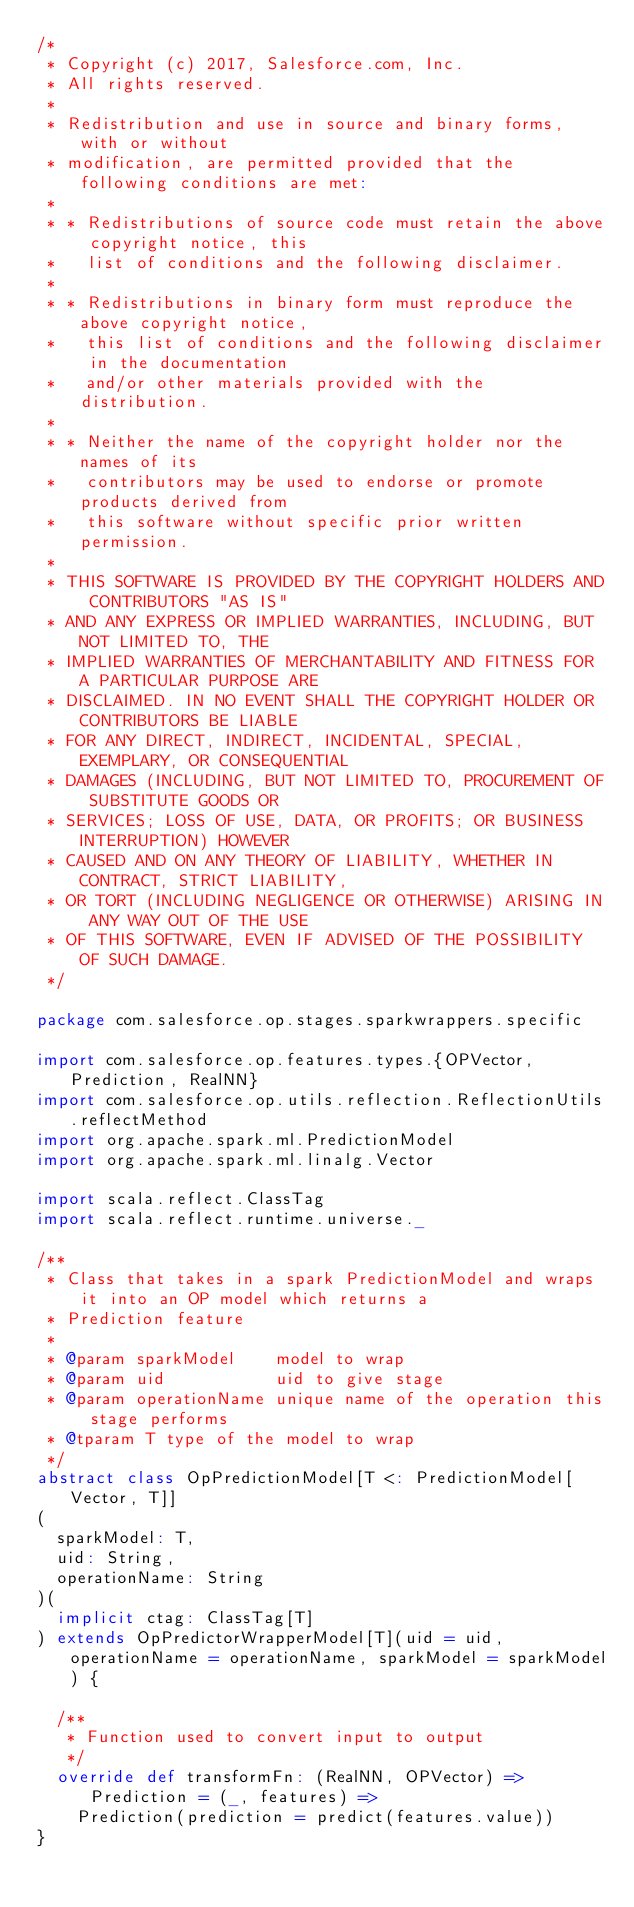<code> <loc_0><loc_0><loc_500><loc_500><_Scala_>/*
 * Copyright (c) 2017, Salesforce.com, Inc.
 * All rights reserved.
 *
 * Redistribution and use in source and binary forms, with or without
 * modification, are permitted provided that the following conditions are met:
 *
 * * Redistributions of source code must retain the above copyright notice, this
 *   list of conditions and the following disclaimer.
 *
 * * Redistributions in binary form must reproduce the above copyright notice,
 *   this list of conditions and the following disclaimer in the documentation
 *   and/or other materials provided with the distribution.
 *
 * * Neither the name of the copyright holder nor the names of its
 *   contributors may be used to endorse or promote products derived from
 *   this software without specific prior written permission.
 *
 * THIS SOFTWARE IS PROVIDED BY THE COPYRIGHT HOLDERS AND CONTRIBUTORS "AS IS"
 * AND ANY EXPRESS OR IMPLIED WARRANTIES, INCLUDING, BUT NOT LIMITED TO, THE
 * IMPLIED WARRANTIES OF MERCHANTABILITY AND FITNESS FOR A PARTICULAR PURPOSE ARE
 * DISCLAIMED. IN NO EVENT SHALL THE COPYRIGHT HOLDER OR CONTRIBUTORS BE LIABLE
 * FOR ANY DIRECT, INDIRECT, INCIDENTAL, SPECIAL, EXEMPLARY, OR CONSEQUENTIAL
 * DAMAGES (INCLUDING, BUT NOT LIMITED TO, PROCUREMENT OF SUBSTITUTE GOODS OR
 * SERVICES; LOSS OF USE, DATA, OR PROFITS; OR BUSINESS INTERRUPTION) HOWEVER
 * CAUSED AND ON ANY THEORY OF LIABILITY, WHETHER IN CONTRACT, STRICT LIABILITY,
 * OR TORT (INCLUDING NEGLIGENCE OR OTHERWISE) ARISING IN ANY WAY OUT OF THE USE
 * OF THIS SOFTWARE, EVEN IF ADVISED OF THE POSSIBILITY OF SUCH DAMAGE.
 */

package com.salesforce.op.stages.sparkwrappers.specific

import com.salesforce.op.features.types.{OPVector, Prediction, RealNN}
import com.salesforce.op.utils.reflection.ReflectionUtils.reflectMethod
import org.apache.spark.ml.PredictionModel
import org.apache.spark.ml.linalg.Vector

import scala.reflect.ClassTag
import scala.reflect.runtime.universe._

/**
 * Class that takes in a spark PredictionModel and wraps it into an OP model which returns a
 * Prediction feature
 *
 * @param sparkModel    model to wrap
 * @param uid           uid to give stage
 * @param operationName unique name of the operation this stage performs
 * @tparam T type of the model to wrap
 */
abstract class OpPredictionModel[T <: PredictionModel[Vector, T]]
(
  sparkModel: T,
  uid: String,
  operationName: String
)(
  implicit ctag: ClassTag[T]
) extends OpPredictorWrapperModel[T](uid = uid, operationName = operationName, sparkModel = sparkModel) {

  /**
   * Function used to convert input to output
   */
  override def transformFn: (RealNN, OPVector) => Prediction = (_, features) =>
    Prediction(prediction = predict(features.value))
}
</code> 